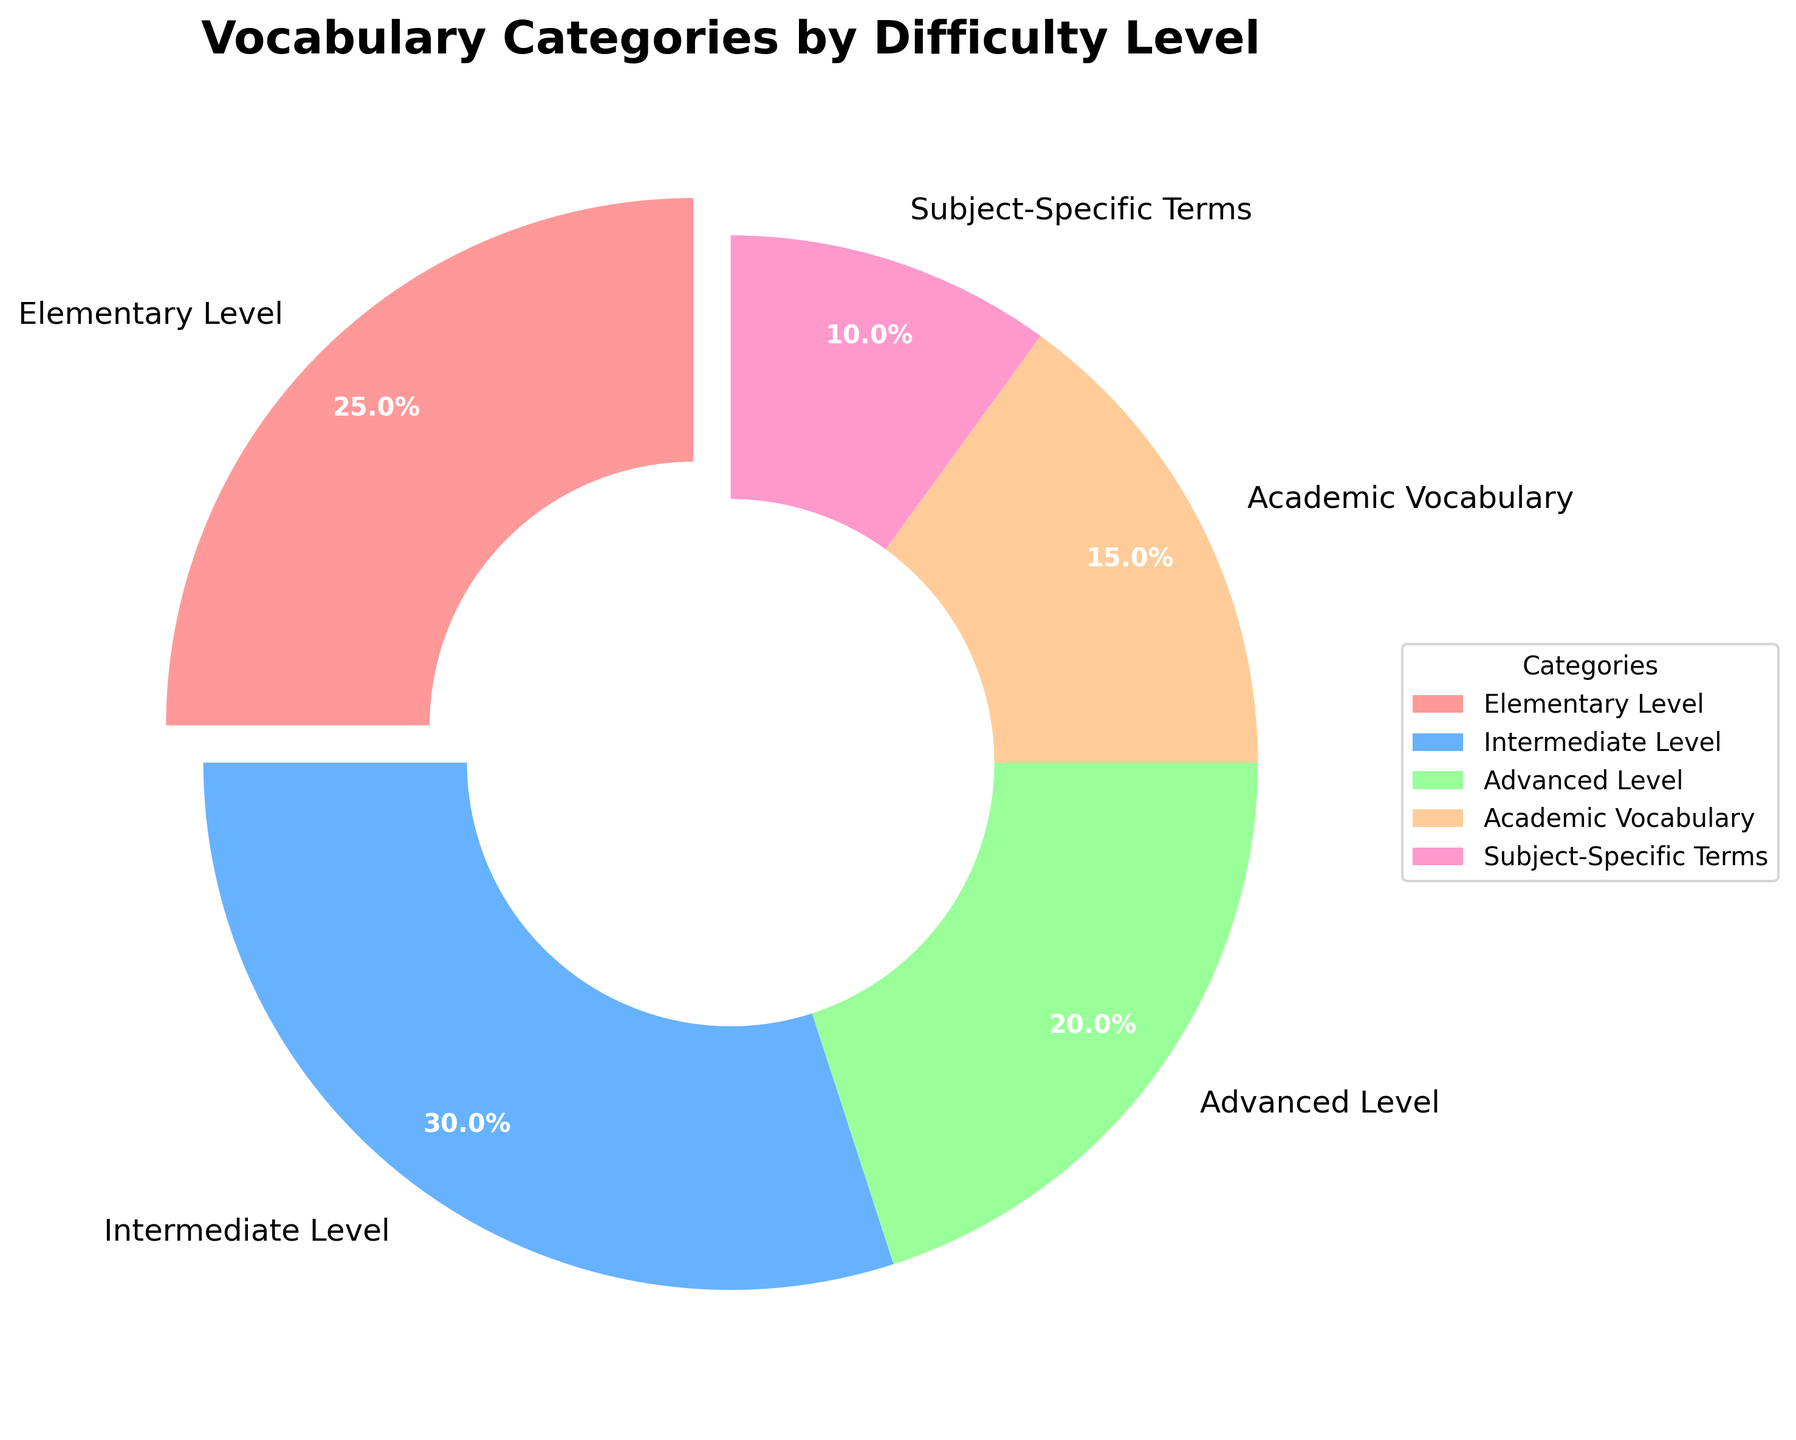Which category has the highest percentage? The highest percentage in the pie chart is represented by the largest slice. The Intermediate Level slice is the largest.
Answer: Intermediate Level Which two categories together make up 50% of the vocabulary words? The Intermediate Level category is 30% and the Elementary Level category is 25%. Together, they make up 55%. The Advanced Level category is 20% and the Academic Vocabulary category is 15%. Together, they make up 35%. Thus, it is Elementary Level and Intermediate Level.
Answer: Elementary Level and Intermediate Level What is the percentage difference between the Elementary Level and Subject-Specific Terms categories? The Elementary Level category is 25% and the Subject-Specific Terms category is 10%. The difference in their percentages is 25% - 10% = 15%.
Answer: 15% What percentage of the vocabulary words are at the Academic Vocabulary level or higher? The categories above the Academic level (Advanced Level and Subject-Specific Terms) are 20% and 10% respectively. The Academic Vocabulary is 15%. Summing these percentages gives 20% + 10% + 15% = 45%.
Answer: 45% If you combine the Elementary Level and Academic Vocabulary, what percentage of the vocabulary words do these two categories represent? The Elementary Level category is 25% and the Academic Vocabulary is 15%. Together, they make up 25% + 15% = 40%.
Answer: 40% How does the percentage for Advanced Level compare to the percentage for Subject-Specific Terms? The Advanced Level category is 20% and the Subject-Specific Terms category is 10%. 20% is double the 10%.
Answer: Advanced Level is double the percentage of Subject-Specific Terms Which slice has a wedge "explosion" effect applied to it? The visual effect of a wedge explosion — where a slice of the pie chart is separated slightly from the rest — is applied to the Elementary Level slice.
Answer: Elementary Level 